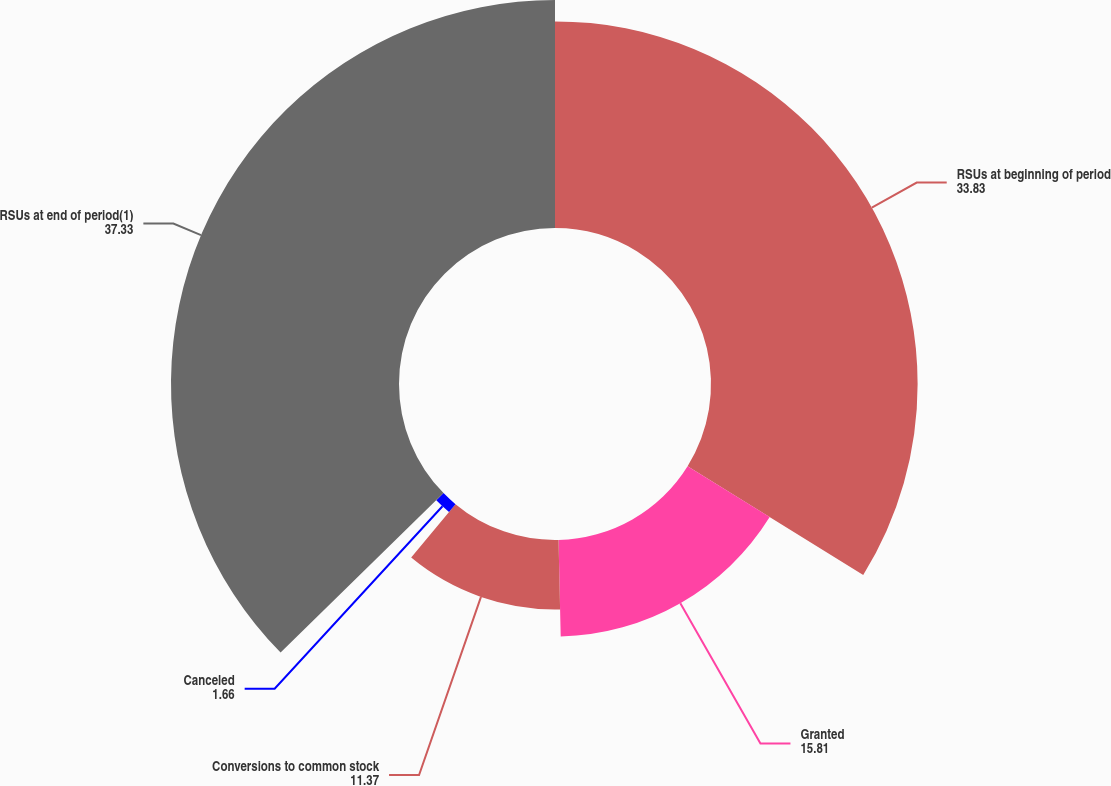<chart> <loc_0><loc_0><loc_500><loc_500><pie_chart><fcel>RSUs at beginning of period<fcel>Granted<fcel>Conversions to common stock<fcel>Canceled<fcel>RSUs at end of period(1)<nl><fcel>33.83%<fcel>15.81%<fcel>11.37%<fcel>1.66%<fcel>37.33%<nl></chart> 